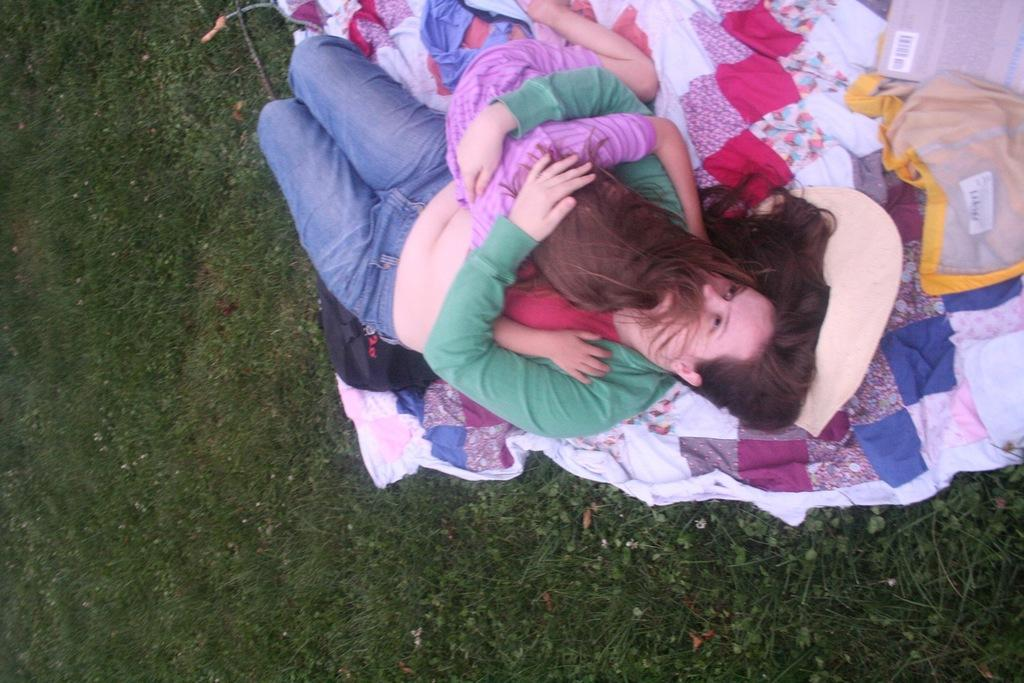Who is the main subject in the image? There is a woman in the image. What is the woman wearing? The woman is wearing a green T-shirt. What is the woman doing in the image? The woman is carrying a child and lying on the grass. What else can be seen in the image besides the woman and the child? There are objects visible in the image. What is the design of the parcel that the woman is holding in the image? There is no parcel present in the image; the woman is carrying a child. 